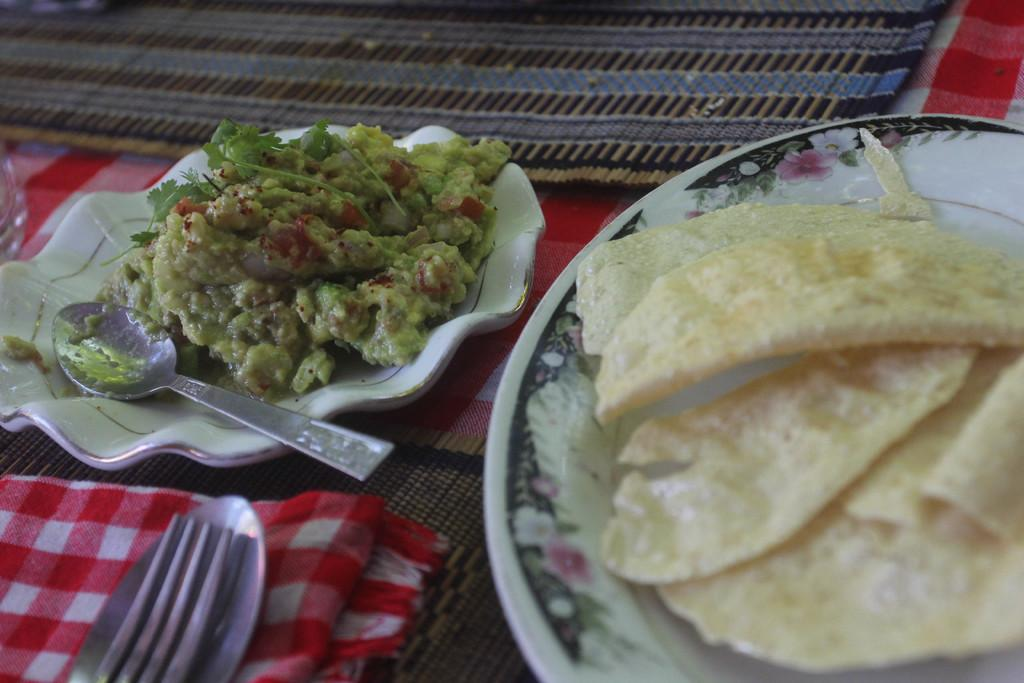What can be seen on the plates in the image? There are two plates with food items in the image. What else is present in the image besides the plates? There is a cloth in the image, as well as a spoon and a fork on the cloth. How many cows are visible in the image? There are no cows visible in the image. What type of beef is being served on the plates? There is no beef present in the image; it only shows plates with food items. 